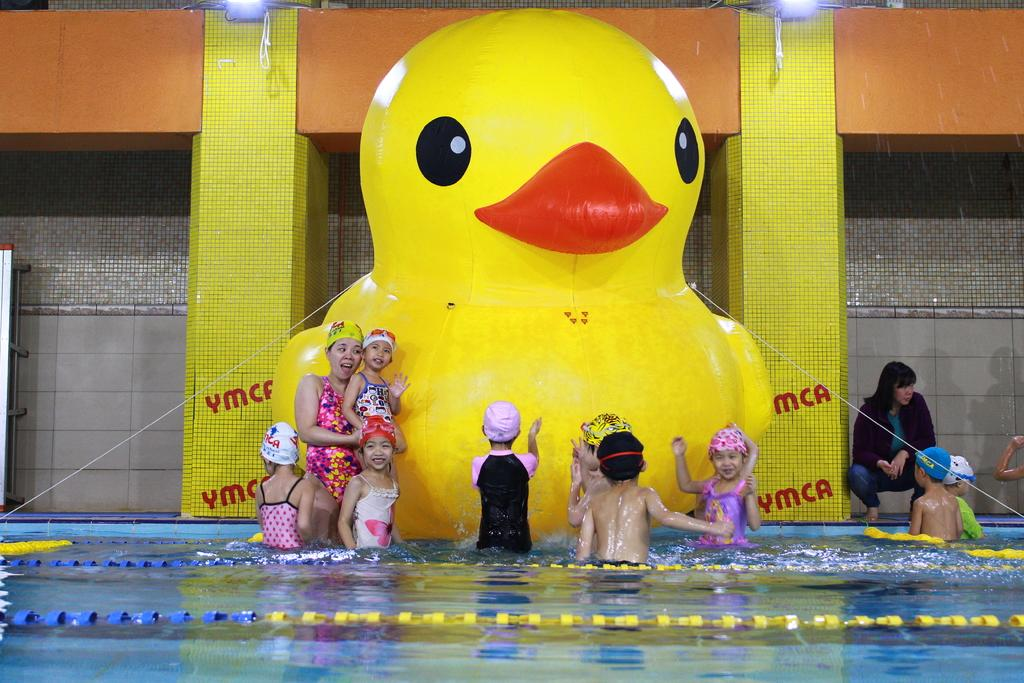How many people are in the image? There are people in the image, but the exact number is not specified. What are some of the people doing in the image? Some people are in a swimming pool. What is an object that is not related to swimming in the image? There is a balloon in the image. What type of structure can be seen in the image? There are pillars in the image. What can be used to provide illumination in the image? There are lights in the image. What type of barrier is present in the image? There is a wall in the image. How many roads can be seen in the image? There are no roads visible in the image. Can you describe the eye color of the people in the image? The image does not provide information about the eye color of the people. 